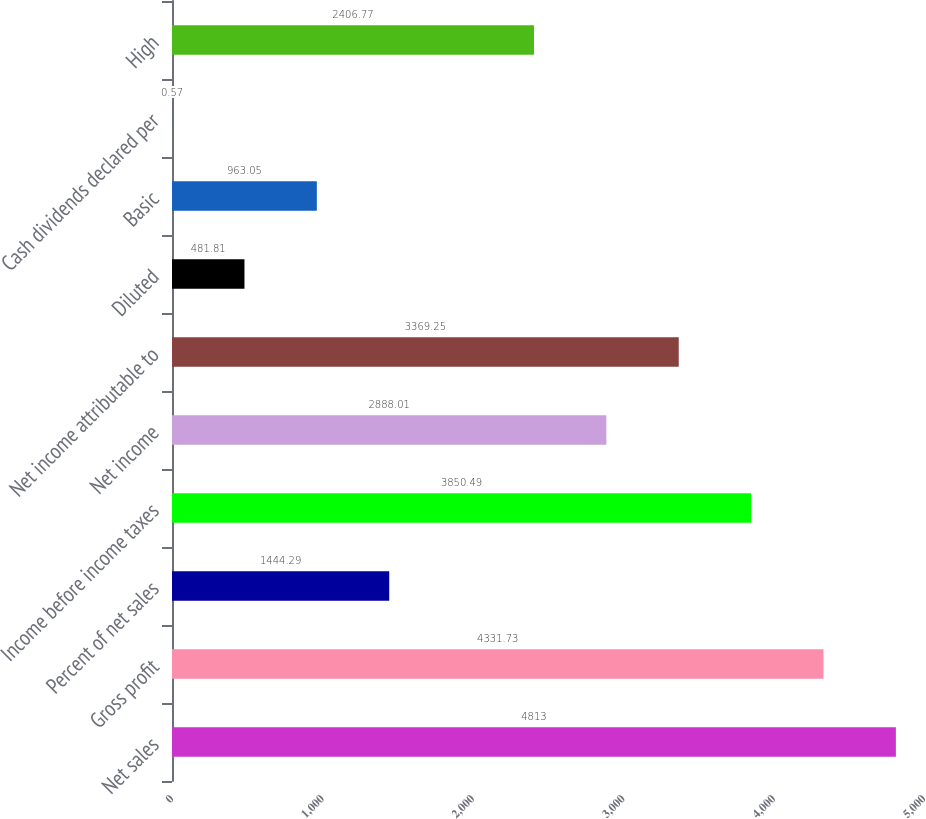<chart> <loc_0><loc_0><loc_500><loc_500><bar_chart><fcel>Net sales<fcel>Gross profit<fcel>Percent of net sales<fcel>Income before income taxes<fcel>Net income<fcel>Net income attributable to<fcel>Diluted<fcel>Basic<fcel>Cash dividends declared per<fcel>High<nl><fcel>4813<fcel>4331.73<fcel>1444.29<fcel>3850.49<fcel>2888.01<fcel>3369.25<fcel>481.81<fcel>963.05<fcel>0.57<fcel>2406.77<nl></chart> 